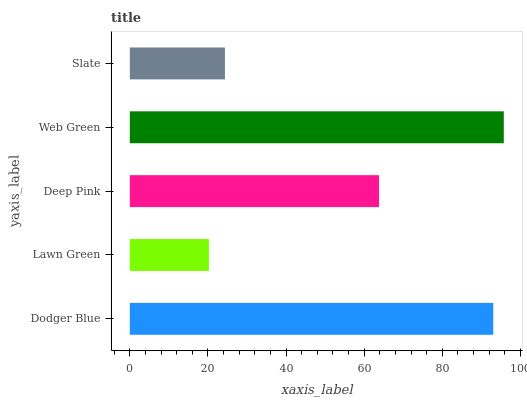Is Lawn Green the minimum?
Answer yes or no. Yes. Is Web Green the maximum?
Answer yes or no. Yes. Is Deep Pink the minimum?
Answer yes or no. No. Is Deep Pink the maximum?
Answer yes or no. No. Is Deep Pink greater than Lawn Green?
Answer yes or no. Yes. Is Lawn Green less than Deep Pink?
Answer yes or no. Yes. Is Lawn Green greater than Deep Pink?
Answer yes or no. No. Is Deep Pink less than Lawn Green?
Answer yes or no. No. Is Deep Pink the high median?
Answer yes or no. Yes. Is Deep Pink the low median?
Answer yes or no. Yes. Is Web Green the high median?
Answer yes or no. No. Is Dodger Blue the low median?
Answer yes or no. No. 